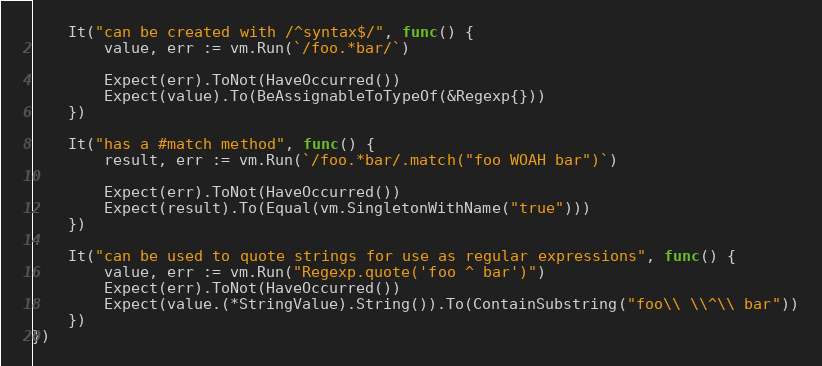Convert code to text. <code><loc_0><loc_0><loc_500><loc_500><_Go_>	It("can be created with /^syntax$/", func() {
		value, err := vm.Run(`/foo.*bar/`)

		Expect(err).ToNot(HaveOccurred())
		Expect(value).To(BeAssignableToTypeOf(&Regexp{}))
	})

	It("has a #match method", func() {
		result, err := vm.Run(`/foo.*bar/.match("foo WOAH bar")`)

		Expect(err).ToNot(HaveOccurred())
		Expect(result).To(Equal(vm.SingletonWithName("true")))
	})

	It("can be used to quote strings for use as regular expressions", func() {
		value, err := vm.Run("Regexp.quote('foo ^ bar')")
		Expect(err).ToNot(HaveOccurred())
		Expect(value.(*StringValue).String()).To(ContainSubstring("foo\\ \\^\\ bar"))
	})
})
</code> 